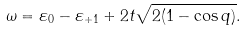<formula> <loc_0><loc_0><loc_500><loc_500>\omega = \varepsilon _ { 0 } - \varepsilon _ { + 1 } + 2 t \sqrt { 2 ( 1 - \cos q ) } .</formula> 